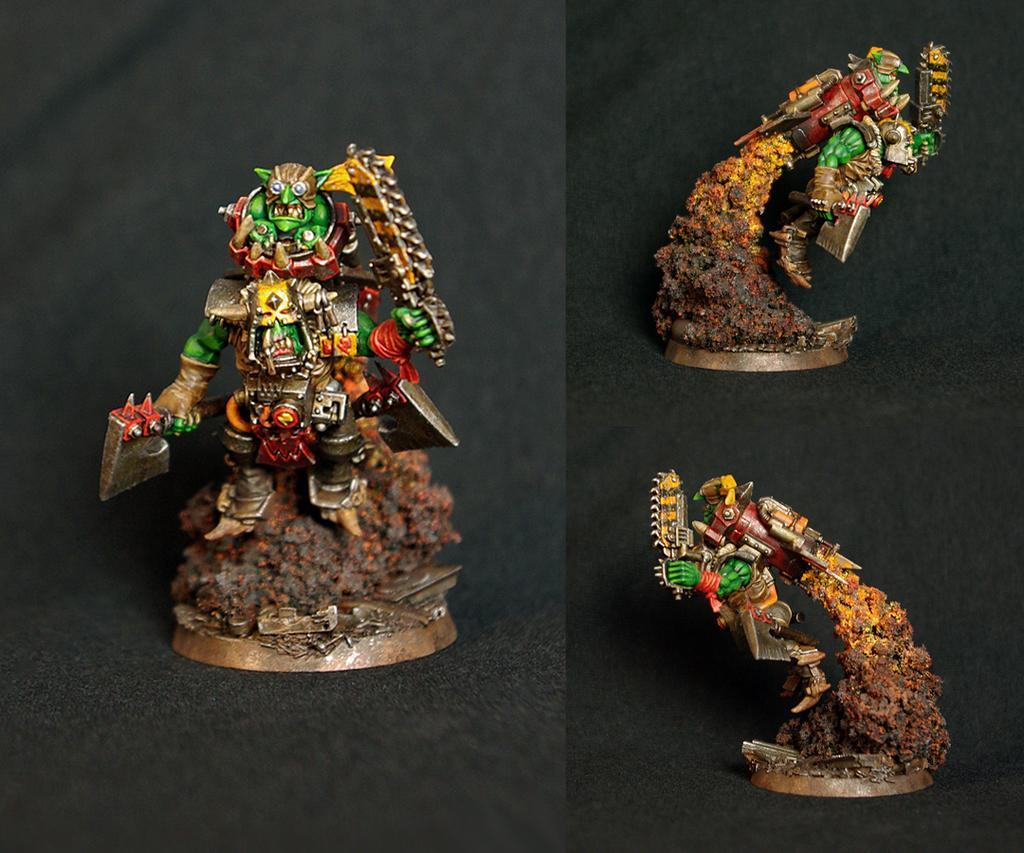In one or two sentences, can you explain what this image depicts? In this picture I can see few miniatures, looks like a collage of two pictures. 